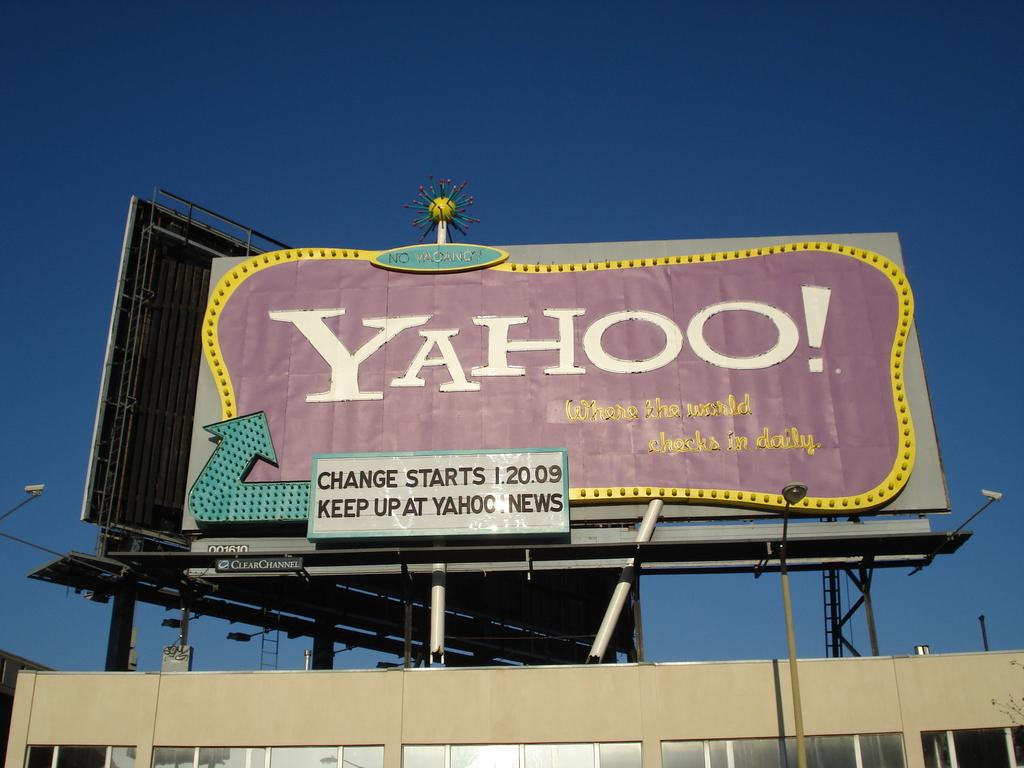What is the sign for?
Offer a very short reply. Yahoo. 